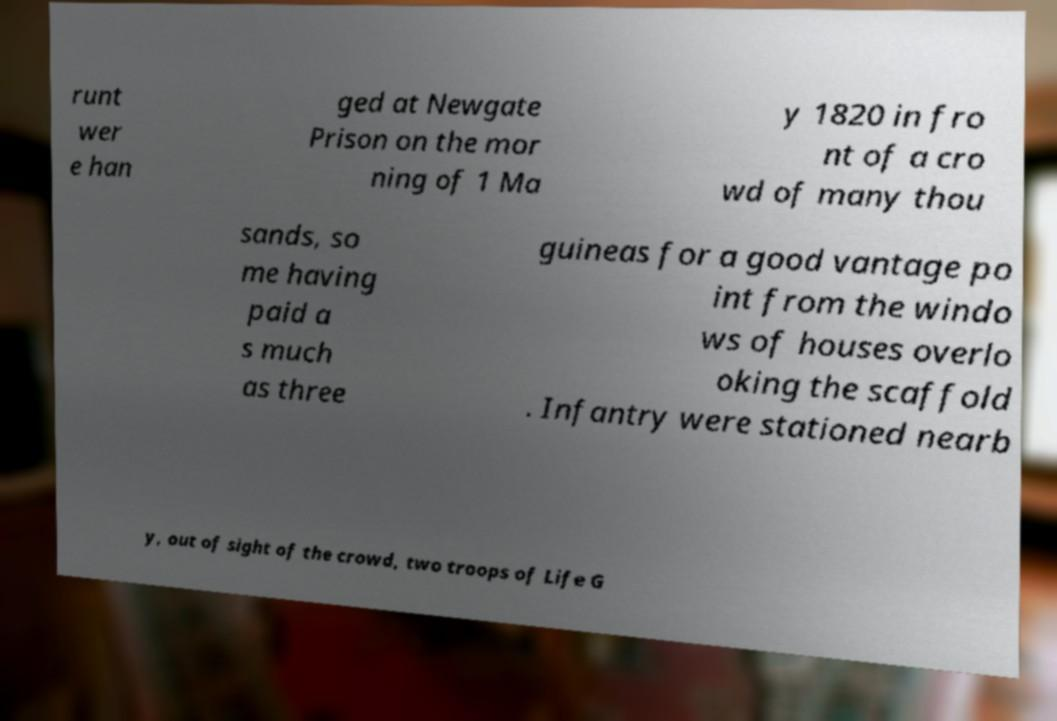Can you accurately transcribe the text from the provided image for me? runt wer e han ged at Newgate Prison on the mor ning of 1 Ma y 1820 in fro nt of a cro wd of many thou sands, so me having paid a s much as three guineas for a good vantage po int from the windo ws of houses overlo oking the scaffold . Infantry were stationed nearb y, out of sight of the crowd, two troops of Life G 